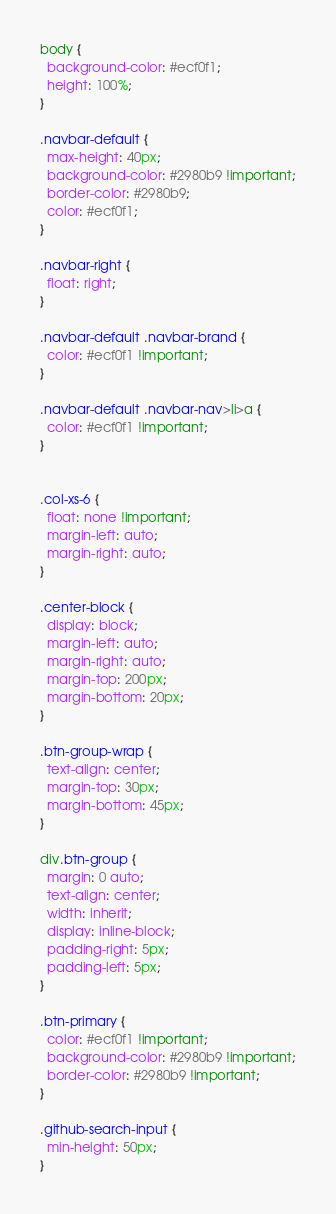<code> <loc_0><loc_0><loc_500><loc_500><_CSS_>body {
  background-color: #ecf0f1;
  height: 100%;
}

.navbar-default {
  max-height: 40px;
  background-color: #2980b9 !important;
  border-color: #2980b9;
  color: #ecf0f1;
}

.navbar-right {
  float: right;
}

.navbar-default .navbar-brand {
  color: #ecf0f1 !important;
}

.navbar-default .navbar-nav>li>a {
  color: #ecf0f1 !important;
}


.col-xs-6 {
  float: none !important;
  margin-left: auto;
  margin-right: auto;
}

.center-block {
  display: block;
  margin-left: auto;
  margin-right: auto;
  margin-top: 200px;
  margin-bottom: 20px;
}

.btn-group-wrap {
  text-align: center;
  margin-top: 30px;
  margin-bottom: 45px;
}

div.btn-group {
  margin: 0 auto;
  text-align: center;
  width: inherit;
  display: inline-block;
  padding-right: 5px;
  padding-left: 5px;
}

.btn-primary {
  color: #ecf0f1 !important;
  background-color: #2980b9 !important;
  border-color: #2980b9 !important;
}

.github-search-input {
  min-height: 50px;
}
</code> 